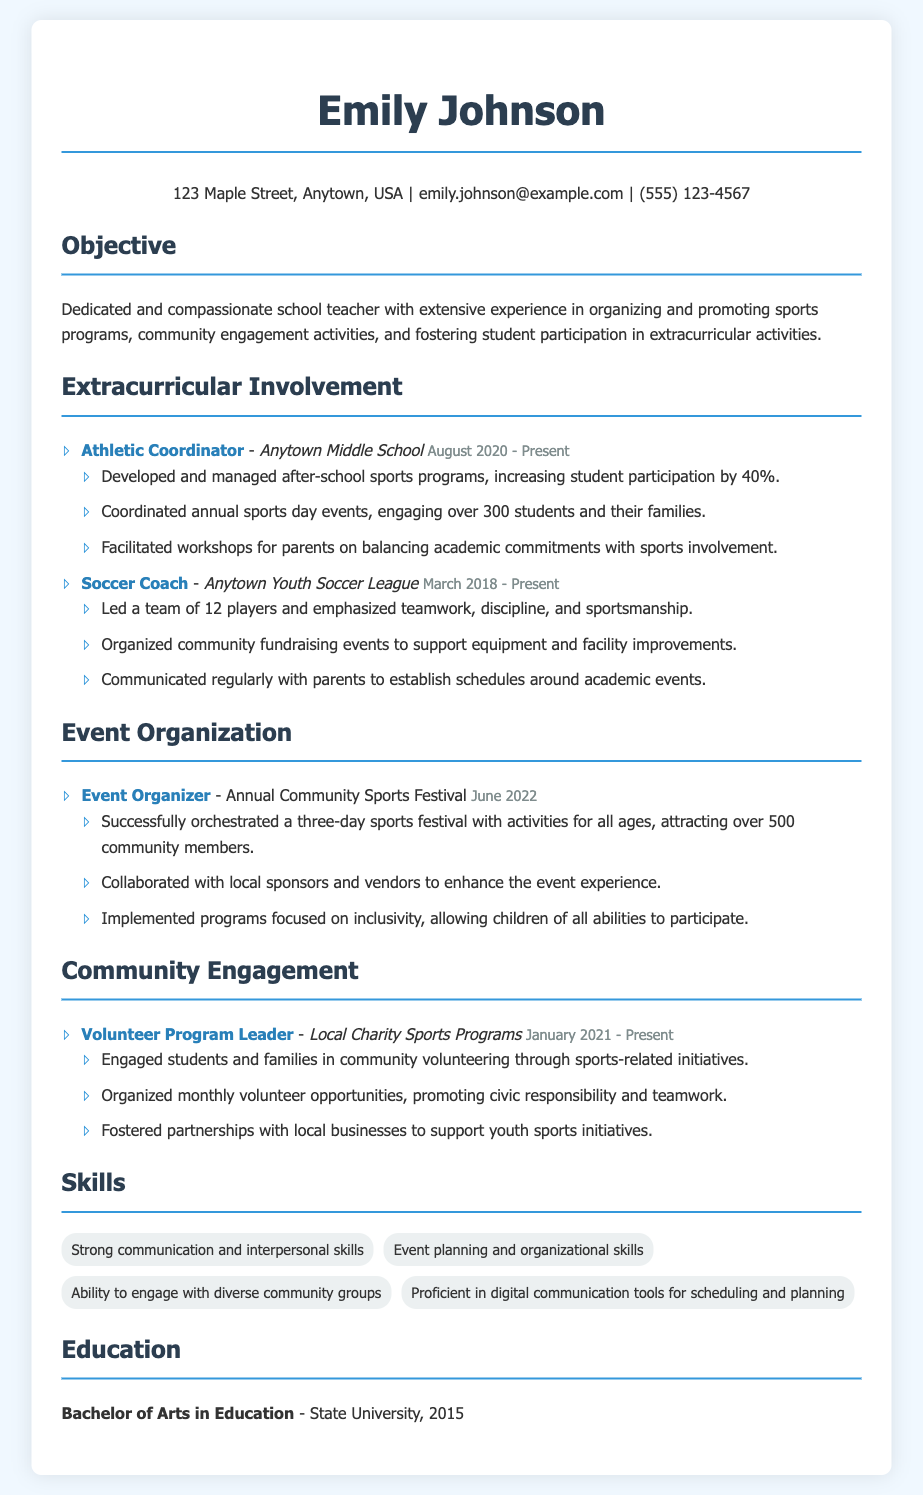What is Emily Johnson's current job title? The current job title is listed as "Athletic Coordinator" at Anytown Middle School.
Answer: Athletic Coordinator When did Emily start her role as a Soccer Coach? The date is specified as March 2018 in her involvement section.
Answer: March 2018 How many players are on the Soccer team that Emily coaches? The number of players that Emily leads is stated as 12 in her responsibilities.
Answer: 12 What percentage increase in student participation did Emily achieve in after-school sports programs? The document states a 40% increase in student participation attributed to her efforts.
Answer: 40% How many community members attended the Annual Community Sports Festival? The document mentions over 500 community members participated in the event.
Answer: 500 What type of events did Emily organize for parents regarding sports involvement? The events are referred to as workshops for parents in the document.
Answer: Workshops What is Emily's educational qualification? The qualification mentioned is a Bachelor of Arts in Education obtained from State University.
Answer: Bachelor of Arts in Education What role does Emily hold in Local Charity Sports Programs? The role specified is "Volunteer Program Leader" for this organization.
Answer: Volunteer Program Leader Which skills are emphasized in Emily's CV? Strong communication, event planning, community engagement, and proficiency in digital tools are highlighted.
Answer: Strong communication and interpersonal skills, Event planning and organizational skills, Ability to engage with diverse community groups, Proficient in digital communication tools for scheduling and planning 